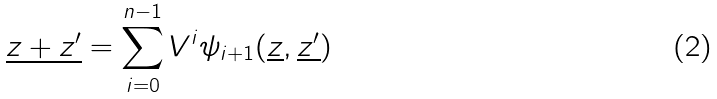Convert formula to latex. <formula><loc_0><loc_0><loc_500><loc_500>\underline { z + z ^ { \prime } } = \sum _ { i = 0 } ^ { n - 1 } V ^ { i } \psi _ { i + 1 } ( \underline { z } , \underline { z ^ { \prime } } )</formula> 